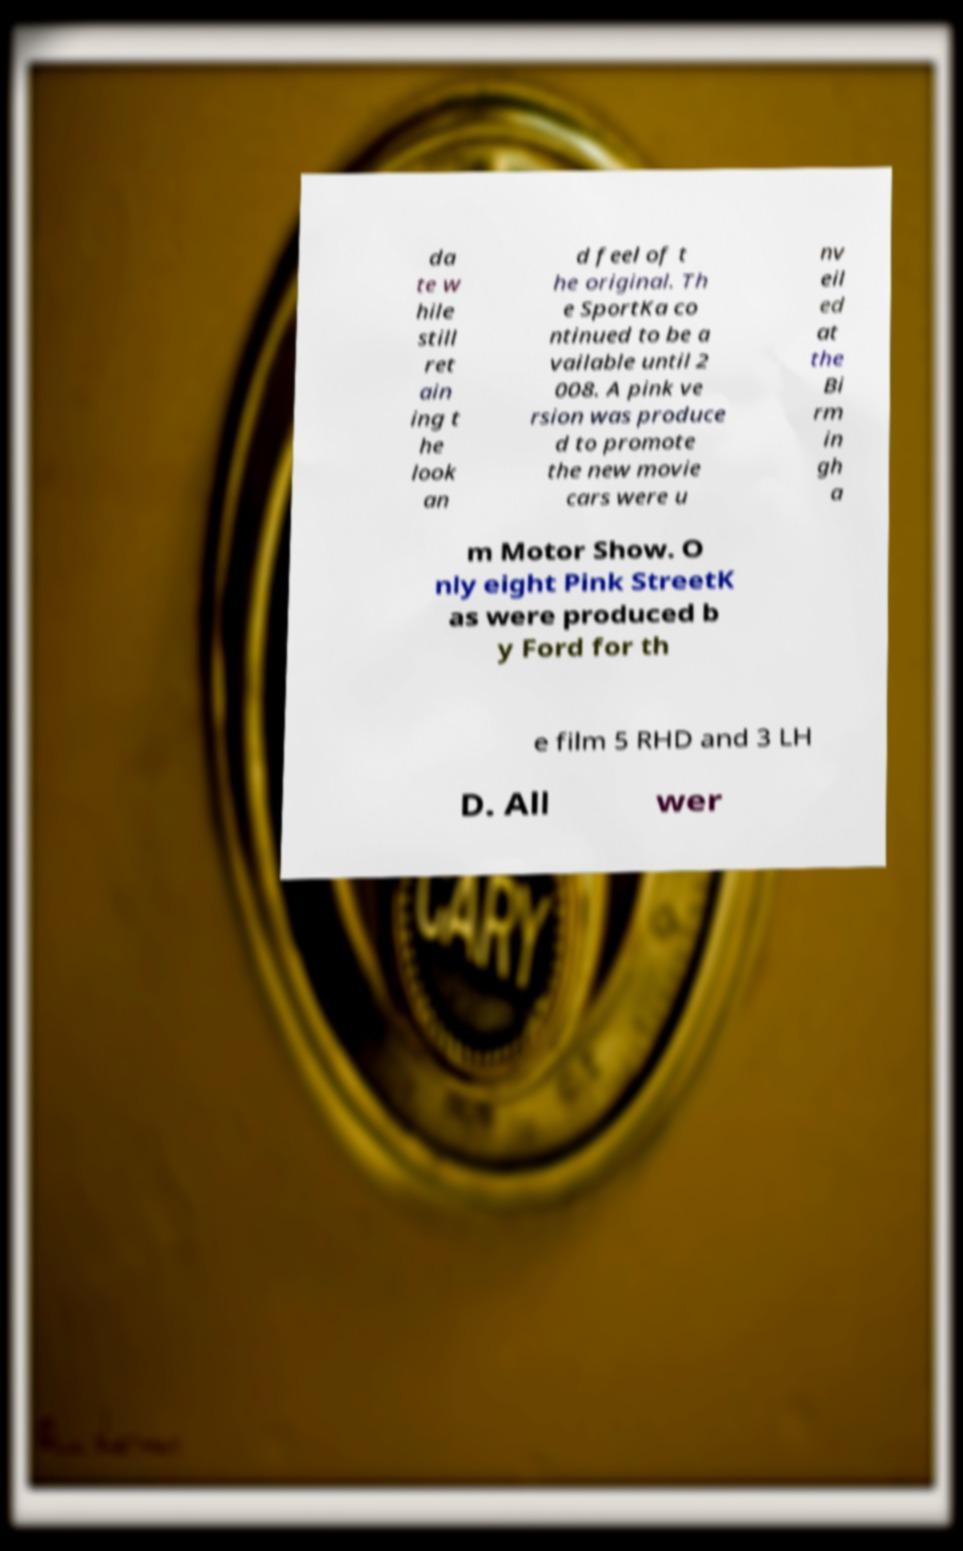Please read and relay the text visible in this image. What does it say? da te w hile still ret ain ing t he look an d feel of t he original. Th e SportKa co ntinued to be a vailable until 2 008. A pink ve rsion was produce d to promote the new movie cars were u nv eil ed at the Bi rm in gh a m Motor Show. O nly eight Pink StreetK as were produced b y Ford for th e film 5 RHD and 3 LH D. All wer 